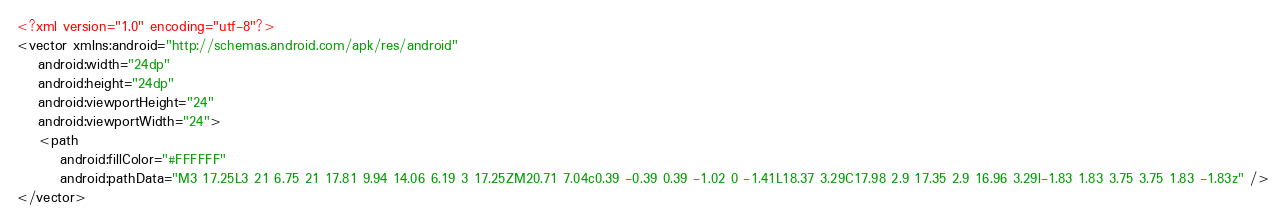Convert code to text. <code><loc_0><loc_0><loc_500><loc_500><_XML_><?xml version="1.0" encoding="utf-8"?>
<vector xmlns:android="http://schemas.android.com/apk/res/android"
    android:width="24dp"
    android:height="24dp"
    android:viewportHeight="24"
    android:viewportWidth="24">
    <path
        android:fillColor="#FFFFFF"
        android:pathData="M3 17.25L3 21 6.75 21 17.81 9.94 14.06 6.19 3 17.25ZM20.71 7.04c0.39 -0.39 0.39 -1.02 0 -1.41L18.37 3.29C17.98 2.9 17.35 2.9 16.96 3.29l-1.83 1.83 3.75 3.75 1.83 -1.83z" />
</vector></code> 